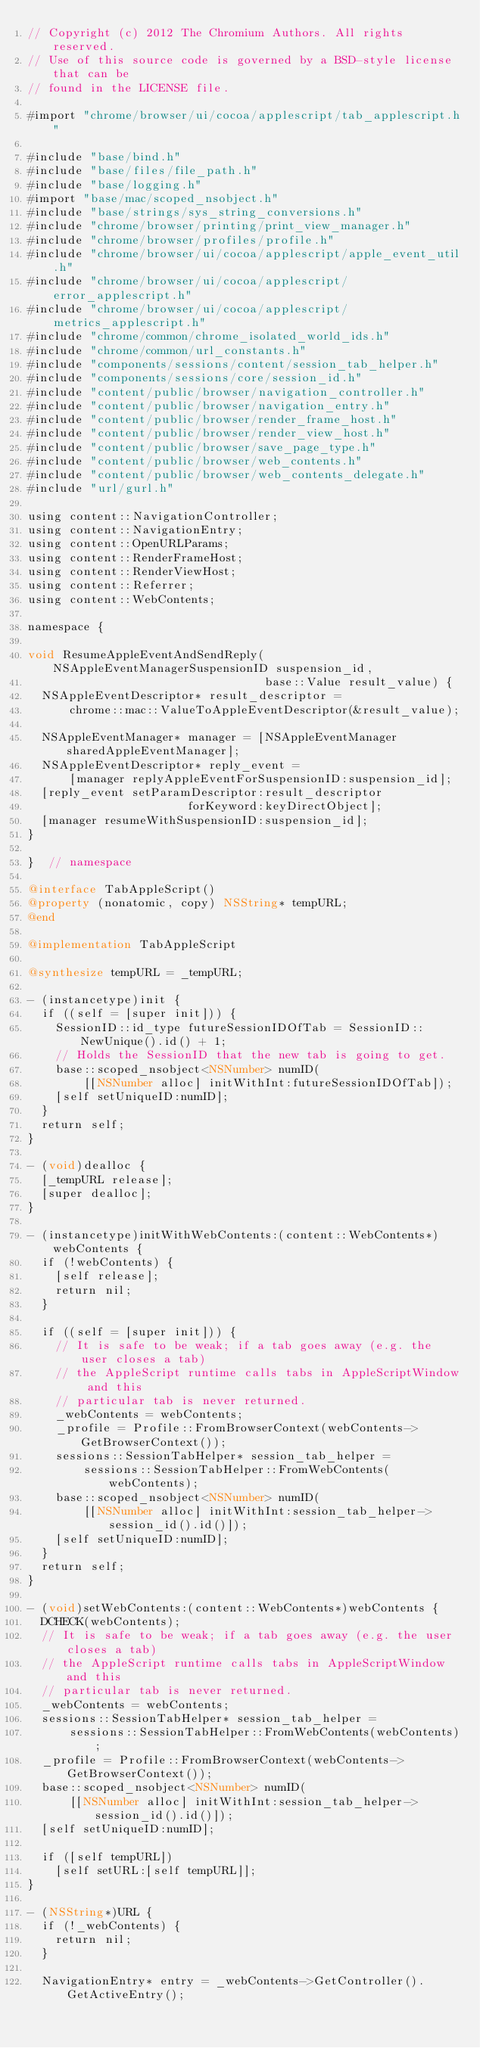<code> <loc_0><loc_0><loc_500><loc_500><_ObjectiveC_>// Copyright (c) 2012 The Chromium Authors. All rights reserved.
// Use of this source code is governed by a BSD-style license that can be
// found in the LICENSE file.

#import "chrome/browser/ui/cocoa/applescript/tab_applescript.h"

#include "base/bind.h"
#include "base/files/file_path.h"
#include "base/logging.h"
#import "base/mac/scoped_nsobject.h"
#include "base/strings/sys_string_conversions.h"
#include "chrome/browser/printing/print_view_manager.h"
#include "chrome/browser/profiles/profile.h"
#include "chrome/browser/ui/cocoa/applescript/apple_event_util.h"
#include "chrome/browser/ui/cocoa/applescript/error_applescript.h"
#include "chrome/browser/ui/cocoa/applescript/metrics_applescript.h"
#include "chrome/common/chrome_isolated_world_ids.h"
#include "chrome/common/url_constants.h"
#include "components/sessions/content/session_tab_helper.h"
#include "components/sessions/core/session_id.h"
#include "content/public/browser/navigation_controller.h"
#include "content/public/browser/navigation_entry.h"
#include "content/public/browser/render_frame_host.h"
#include "content/public/browser/render_view_host.h"
#include "content/public/browser/save_page_type.h"
#include "content/public/browser/web_contents.h"
#include "content/public/browser/web_contents_delegate.h"
#include "url/gurl.h"

using content::NavigationController;
using content::NavigationEntry;
using content::OpenURLParams;
using content::RenderFrameHost;
using content::RenderViewHost;
using content::Referrer;
using content::WebContents;

namespace {

void ResumeAppleEventAndSendReply(NSAppleEventManagerSuspensionID suspension_id,
                                  base::Value result_value) {
  NSAppleEventDescriptor* result_descriptor =
      chrome::mac::ValueToAppleEventDescriptor(&result_value);

  NSAppleEventManager* manager = [NSAppleEventManager sharedAppleEventManager];
  NSAppleEventDescriptor* reply_event =
      [manager replyAppleEventForSuspensionID:suspension_id];
  [reply_event setParamDescriptor:result_descriptor
                       forKeyword:keyDirectObject];
  [manager resumeWithSuspensionID:suspension_id];
}

}  // namespace

@interface TabAppleScript()
@property (nonatomic, copy) NSString* tempURL;
@end

@implementation TabAppleScript

@synthesize tempURL = _tempURL;

- (instancetype)init {
  if ((self = [super init])) {
    SessionID::id_type futureSessionIDOfTab = SessionID::NewUnique().id() + 1;
    // Holds the SessionID that the new tab is going to get.
    base::scoped_nsobject<NSNumber> numID(
        [[NSNumber alloc] initWithInt:futureSessionIDOfTab]);
    [self setUniqueID:numID];
  }
  return self;
}

- (void)dealloc {
  [_tempURL release];
  [super dealloc];
}

- (instancetype)initWithWebContents:(content::WebContents*)webContents {
  if (!webContents) {
    [self release];
    return nil;
  }

  if ((self = [super init])) {
    // It is safe to be weak; if a tab goes away (e.g. the user closes a tab)
    // the AppleScript runtime calls tabs in AppleScriptWindow and this
    // particular tab is never returned.
    _webContents = webContents;
    _profile = Profile::FromBrowserContext(webContents->GetBrowserContext());
    sessions::SessionTabHelper* session_tab_helper =
        sessions::SessionTabHelper::FromWebContents(webContents);
    base::scoped_nsobject<NSNumber> numID(
        [[NSNumber alloc] initWithInt:session_tab_helper->session_id().id()]);
    [self setUniqueID:numID];
  }
  return self;
}

- (void)setWebContents:(content::WebContents*)webContents {
  DCHECK(webContents);
  // It is safe to be weak; if a tab goes away (e.g. the user closes a tab)
  // the AppleScript runtime calls tabs in AppleScriptWindow and this
  // particular tab is never returned.
  _webContents = webContents;
  sessions::SessionTabHelper* session_tab_helper =
      sessions::SessionTabHelper::FromWebContents(webContents);
  _profile = Profile::FromBrowserContext(webContents->GetBrowserContext());
  base::scoped_nsobject<NSNumber> numID(
      [[NSNumber alloc] initWithInt:session_tab_helper->session_id().id()]);
  [self setUniqueID:numID];

  if ([self tempURL])
    [self setURL:[self tempURL]];
}

- (NSString*)URL {
  if (!_webContents) {
    return nil;
  }

  NavigationEntry* entry = _webContents->GetController().GetActiveEntry();</code> 